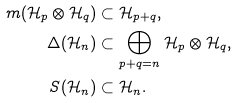<formula> <loc_0><loc_0><loc_500><loc_500>m ( \mathcal { H } _ { p } \otimes \mathcal { H } _ { q } ) & \subset \mathcal { H } _ { p + q } , \\ \Delta ( \mathcal { H } _ { n } ) & \subset \bigoplus _ { p + q = n } \mathcal { H } _ { p } \otimes \mathcal { H } _ { q } , \\ S ( \mathcal { H } _ { n } ) & \subset \mathcal { H } _ { n } .</formula> 